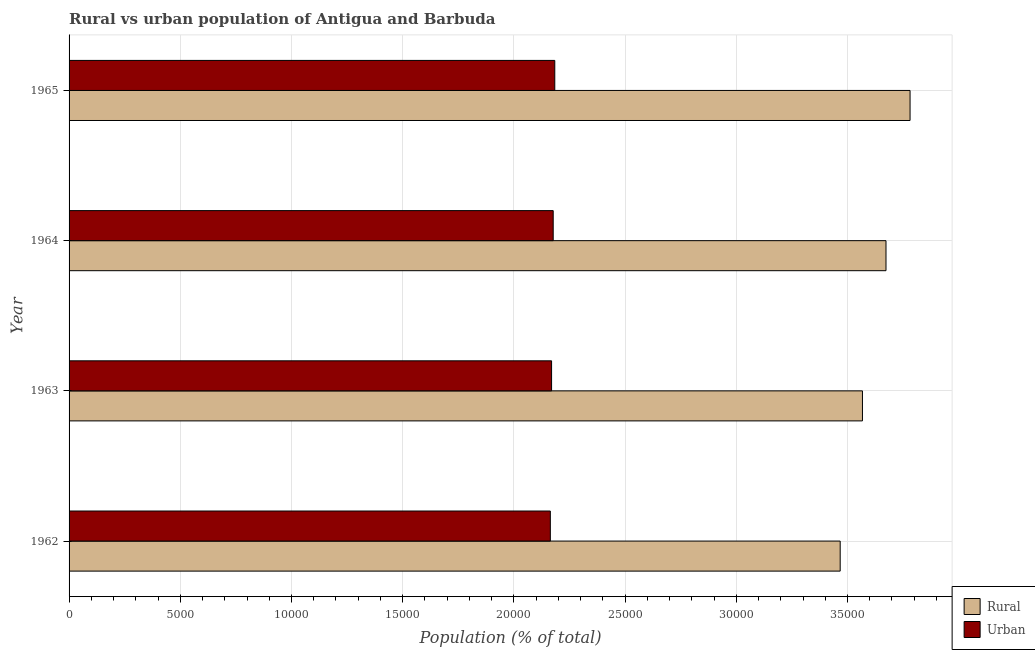How many groups of bars are there?
Provide a short and direct response. 4. Are the number of bars per tick equal to the number of legend labels?
Make the answer very short. Yes. How many bars are there on the 2nd tick from the top?
Offer a terse response. 2. In how many cases, is the number of bars for a given year not equal to the number of legend labels?
Make the answer very short. 0. What is the rural population density in 1964?
Your answer should be very brief. 3.67e+04. Across all years, what is the maximum rural population density?
Your answer should be compact. 3.78e+04. Across all years, what is the minimum rural population density?
Make the answer very short. 3.47e+04. In which year was the rural population density maximum?
Keep it short and to the point. 1965. In which year was the rural population density minimum?
Your response must be concise. 1962. What is the total urban population density in the graph?
Your response must be concise. 8.69e+04. What is the difference between the rural population density in 1964 and that in 1965?
Your answer should be very brief. -1082. What is the difference between the urban population density in 1962 and the rural population density in 1964?
Keep it short and to the point. -1.51e+04. What is the average rural population density per year?
Ensure brevity in your answer.  3.62e+04. In the year 1963, what is the difference between the rural population density and urban population density?
Offer a terse response. 1.40e+04. What is the ratio of the rural population density in 1963 to that in 1965?
Make the answer very short. 0.94. Is the urban population density in 1962 less than that in 1964?
Keep it short and to the point. Yes. Is the difference between the urban population density in 1962 and 1965 greater than the difference between the rural population density in 1962 and 1965?
Keep it short and to the point. Yes. What is the difference between the highest and the second highest rural population density?
Your answer should be very brief. 1082. What is the difference between the highest and the lowest rural population density?
Offer a very short reply. 3142. What does the 1st bar from the top in 1964 represents?
Offer a very short reply. Urban. What does the 2nd bar from the bottom in 1963 represents?
Offer a very short reply. Urban. What is the difference between two consecutive major ticks on the X-axis?
Make the answer very short. 5000. Does the graph contain any zero values?
Provide a short and direct response. No. How many legend labels are there?
Offer a very short reply. 2. What is the title of the graph?
Your answer should be compact. Rural vs urban population of Antigua and Barbuda. What is the label or title of the X-axis?
Your response must be concise. Population (% of total). What is the Population (% of total) of Rural in 1962?
Provide a succinct answer. 3.47e+04. What is the Population (% of total) in Urban in 1962?
Make the answer very short. 2.16e+04. What is the Population (% of total) of Rural in 1963?
Keep it short and to the point. 3.57e+04. What is the Population (% of total) of Urban in 1963?
Provide a short and direct response. 2.17e+04. What is the Population (% of total) in Rural in 1964?
Offer a very short reply. 3.67e+04. What is the Population (% of total) in Urban in 1964?
Your answer should be compact. 2.18e+04. What is the Population (% of total) of Rural in 1965?
Your answer should be compact. 3.78e+04. What is the Population (% of total) in Urban in 1965?
Your response must be concise. 2.18e+04. Across all years, what is the maximum Population (% of total) in Rural?
Make the answer very short. 3.78e+04. Across all years, what is the maximum Population (% of total) of Urban?
Ensure brevity in your answer.  2.18e+04. Across all years, what is the minimum Population (% of total) of Rural?
Your response must be concise. 3.47e+04. Across all years, what is the minimum Population (% of total) of Urban?
Ensure brevity in your answer.  2.16e+04. What is the total Population (% of total) in Rural in the graph?
Your response must be concise. 1.45e+05. What is the total Population (% of total) in Urban in the graph?
Keep it short and to the point. 8.69e+04. What is the difference between the Population (% of total) of Rural in 1962 and that in 1963?
Give a very brief answer. -1001. What is the difference between the Population (% of total) in Urban in 1962 and that in 1963?
Ensure brevity in your answer.  -56. What is the difference between the Population (% of total) in Rural in 1962 and that in 1964?
Provide a succinct answer. -2060. What is the difference between the Population (% of total) in Urban in 1962 and that in 1964?
Make the answer very short. -129. What is the difference between the Population (% of total) of Rural in 1962 and that in 1965?
Offer a terse response. -3142. What is the difference between the Population (% of total) of Urban in 1962 and that in 1965?
Ensure brevity in your answer.  -200. What is the difference between the Population (% of total) in Rural in 1963 and that in 1964?
Offer a terse response. -1059. What is the difference between the Population (% of total) in Urban in 1963 and that in 1964?
Your response must be concise. -73. What is the difference between the Population (% of total) of Rural in 1963 and that in 1965?
Offer a very short reply. -2141. What is the difference between the Population (% of total) in Urban in 1963 and that in 1965?
Provide a short and direct response. -144. What is the difference between the Population (% of total) in Rural in 1964 and that in 1965?
Provide a succinct answer. -1082. What is the difference between the Population (% of total) in Urban in 1964 and that in 1965?
Provide a succinct answer. -71. What is the difference between the Population (% of total) of Rural in 1962 and the Population (% of total) of Urban in 1963?
Ensure brevity in your answer.  1.30e+04. What is the difference between the Population (% of total) of Rural in 1962 and the Population (% of total) of Urban in 1964?
Give a very brief answer. 1.29e+04. What is the difference between the Population (% of total) of Rural in 1962 and the Population (% of total) of Urban in 1965?
Keep it short and to the point. 1.28e+04. What is the difference between the Population (% of total) of Rural in 1963 and the Population (% of total) of Urban in 1964?
Make the answer very short. 1.39e+04. What is the difference between the Population (% of total) of Rural in 1963 and the Population (% of total) of Urban in 1965?
Offer a terse response. 1.38e+04. What is the difference between the Population (% of total) of Rural in 1964 and the Population (% of total) of Urban in 1965?
Make the answer very short. 1.49e+04. What is the average Population (% of total) in Rural per year?
Give a very brief answer. 3.62e+04. What is the average Population (% of total) in Urban per year?
Your answer should be very brief. 2.17e+04. In the year 1962, what is the difference between the Population (% of total) in Rural and Population (% of total) in Urban?
Offer a very short reply. 1.30e+04. In the year 1963, what is the difference between the Population (% of total) of Rural and Population (% of total) of Urban?
Provide a succinct answer. 1.40e+04. In the year 1964, what is the difference between the Population (% of total) of Rural and Population (% of total) of Urban?
Your answer should be compact. 1.50e+04. In the year 1965, what is the difference between the Population (% of total) in Rural and Population (% of total) in Urban?
Provide a succinct answer. 1.60e+04. What is the ratio of the Population (% of total) in Rural in 1962 to that in 1963?
Provide a succinct answer. 0.97. What is the ratio of the Population (% of total) of Urban in 1962 to that in 1963?
Your answer should be compact. 1. What is the ratio of the Population (% of total) of Rural in 1962 to that in 1964?
Give a very brief answer. 0.94. What is the ratio of the Population (% of total) of Rural in 1962 to that in 1965?
Provide a succinct answer. 0.92. What is the ratio of the Population (% of total) in Urban in 1962 to that in 1965?
Keep it short and to the point. 0.99. What is the ratio of the Population (% of total) in Rural in 1963 to that in 1964?
Ensure brevity in your answer.  0.97. What is the ratio of the Population (% of total) of Urban in 1963 to that in 1964?
Offer a very short reply. 1. What is the ratio of the Population (% of total) of Rural in 1963 to that in 1965?
Provide a short and direct response. 0.94. What is the ratio of the Population (% of total) of Urban in 1963 to that in 1965?
Your response must be concise. 0.99. What is the ratio of the Population (% of total) of Rural in 1964 to that in 1965?
Provide a short and direct response. 0.97. What is the difference between the highest and the second highest Population (% of total) in Rural?
Offer a very short reply. 1082. What is the difference between the highest and the second highest Population (% of total) of Urban?
Keep it short and to the point. 71. What is the difference between the highest and the lowest Population (% of total) of Rural?
Your answer should be very brief. 3142. What is the difference between the highest and the lowest Population (% of total) of Urban?
Give a very brief answer. 200. 